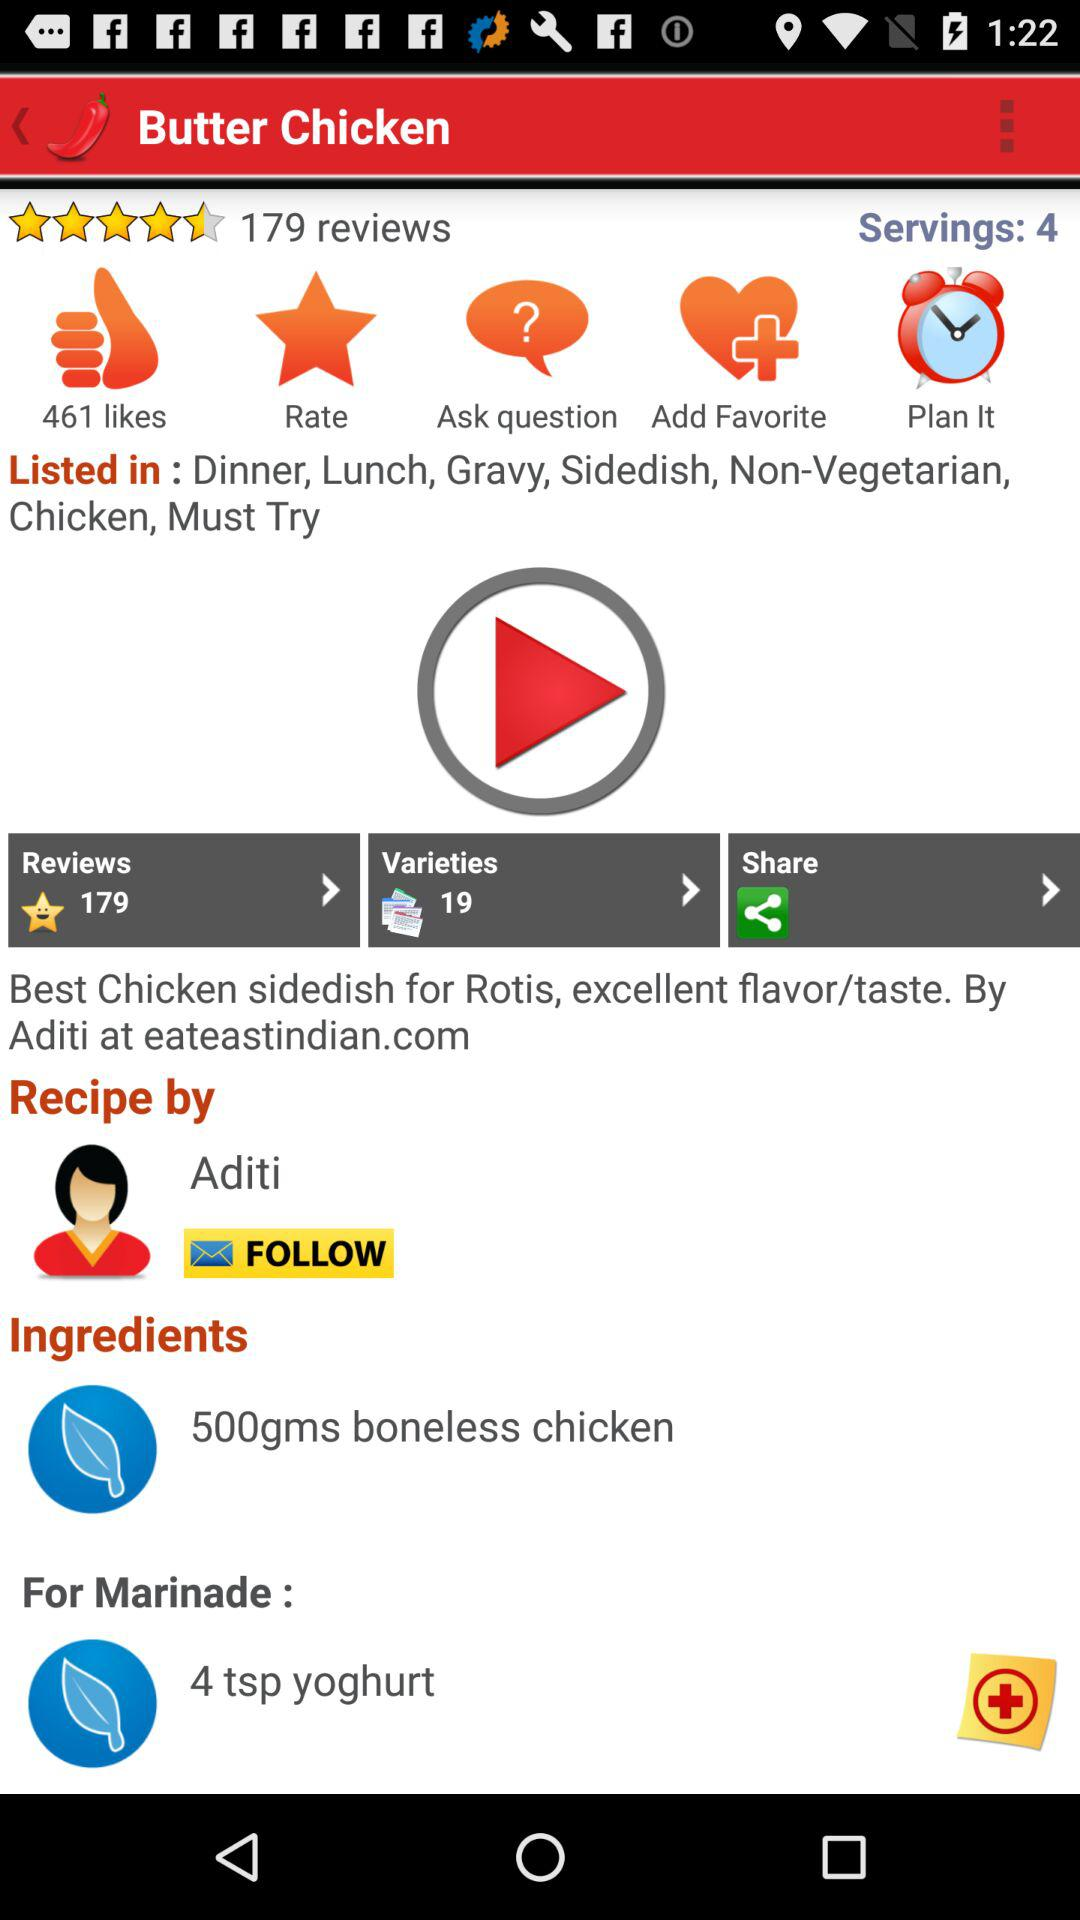How many reviews are there for "Butter Chicken"? There are 179 reviews. 